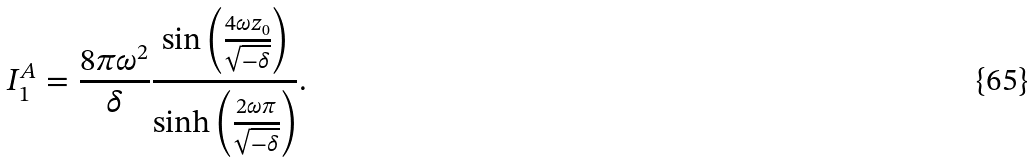Convert formula to latex. <formula><loc_0><loc_0><loc_500><loc_500>I _ { 1 } ^ { A } = \frac { 8 \pi \omega ^ { 2 } } { \delta } \frac { \sin \left ( \frac { 4 \omega z _ { 0 } } { \sqrt { - \delta } } \right ) } { \sinh \left ( \frac { 2 \omega \pi } { \sqrt { - \delta } } \right ) } .</formula> 